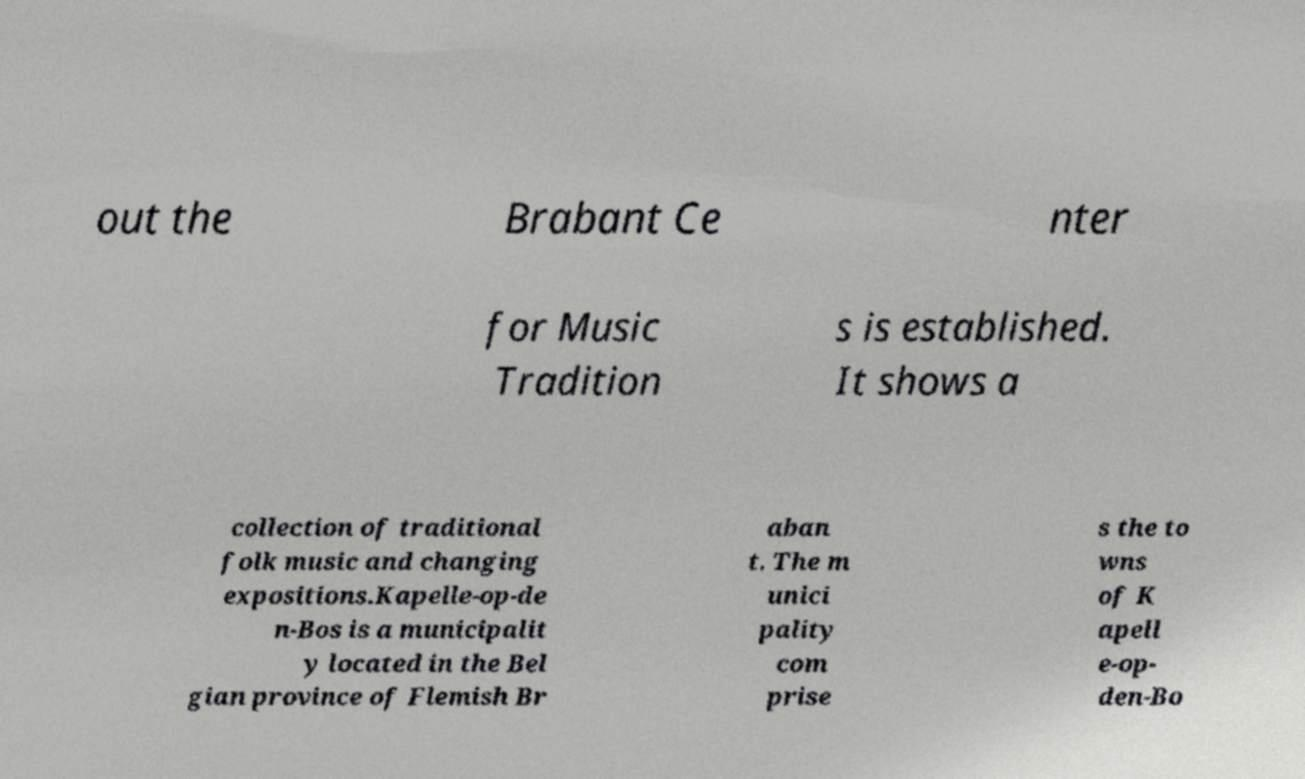For documentation purposes, I need the text within this image transcribed. Could you provide that? out the Brabant Ce nter for Music Tradition s is established. It shows a collection of traditional folk music and changing expositions.Kapelle-op-de n-Bos is a municipalit y located in the Bel gian province of Flemish Br aban t. The m unici pality com prise s the to wns of K apell e-op- den-Bo 